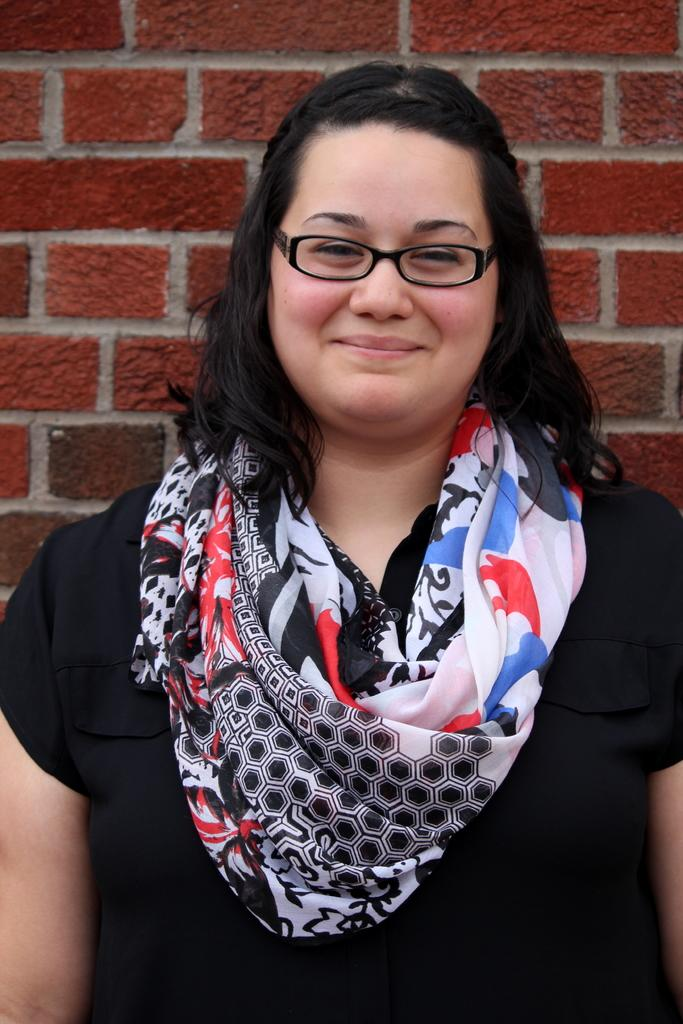Who is the main subject in the image? There is a woman in the image. What is the woman doing in the image? The woman is standing and smiling. What is the woman wearing in the image? The woman is wearing a black T-shirt. What can be seen in the background of the image? There is a wall in the background of the image. Can you describe the painting on the wall? The painting on the wall is of a red color brick wall. How many boats are visible in the image? There are no boats present in the image. What type of metal is used to create the woman's T-shirt in the image? The woman's T-shirt is not made of metal; it is a black T-shirt made of fabric. 